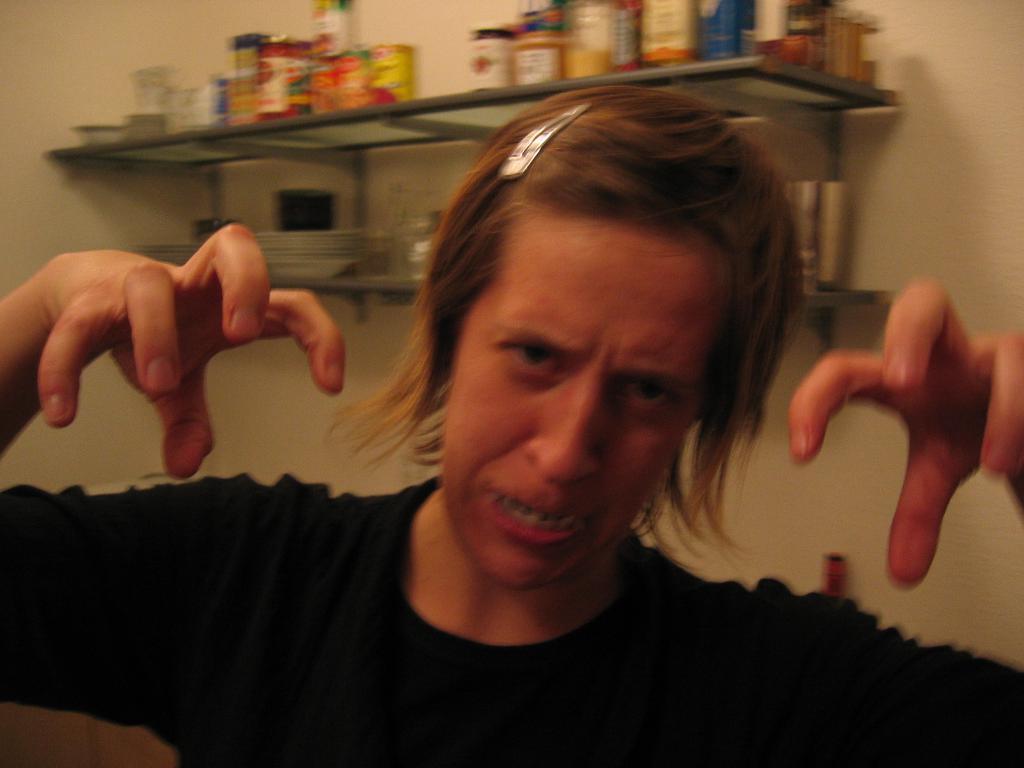Please provide a concise description of this image. In this picture we can observe a woman wearing a black color dress. Behind her there are two racks in which we can observe some bottles and plates. In the background there is a wall which is in white color. 